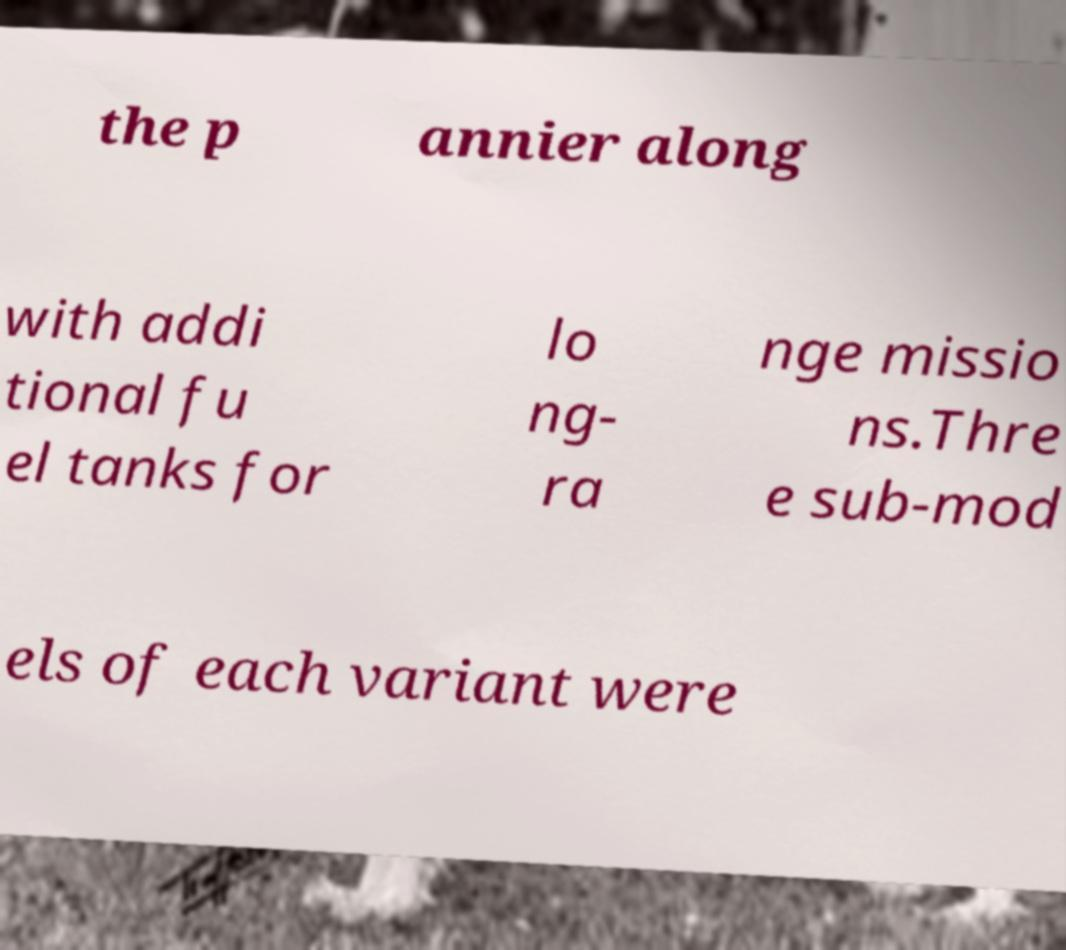Can you read and provide the text displayed in the image?This photo seems to have some interesting text. Can you extract and type it out for me? the p annier along with addi tional fu el tanks for lo ng- ra nge missio ns.Thre e sub-mod els of each variant were 